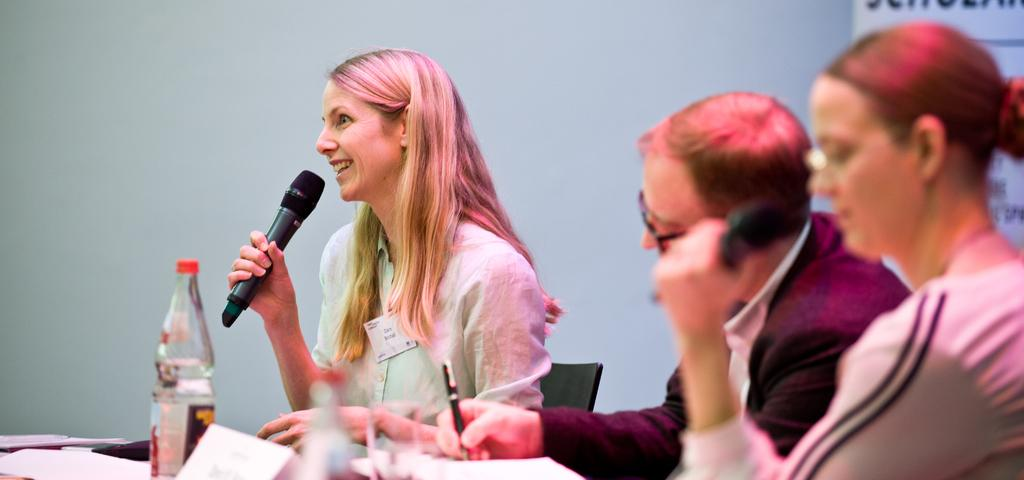How many people are seated in the image? There are three people seated in the image. What is the person on the left doing? The person on the left is holding a microphone and speaking. What is the person in the center holding? The person in the center is holding a pen. What objects are in front of the people? There are glass objects and bottles in front of them. What type of dinner is being served in the image? There is no dinner present in the image; it features three people seated with a microphone, a pen, glass objects, and bottles in front of them. Where is the middle person located in the image? The image does not have a "middle" person, as there are only three people seated, and they are on the left, center, and right. 